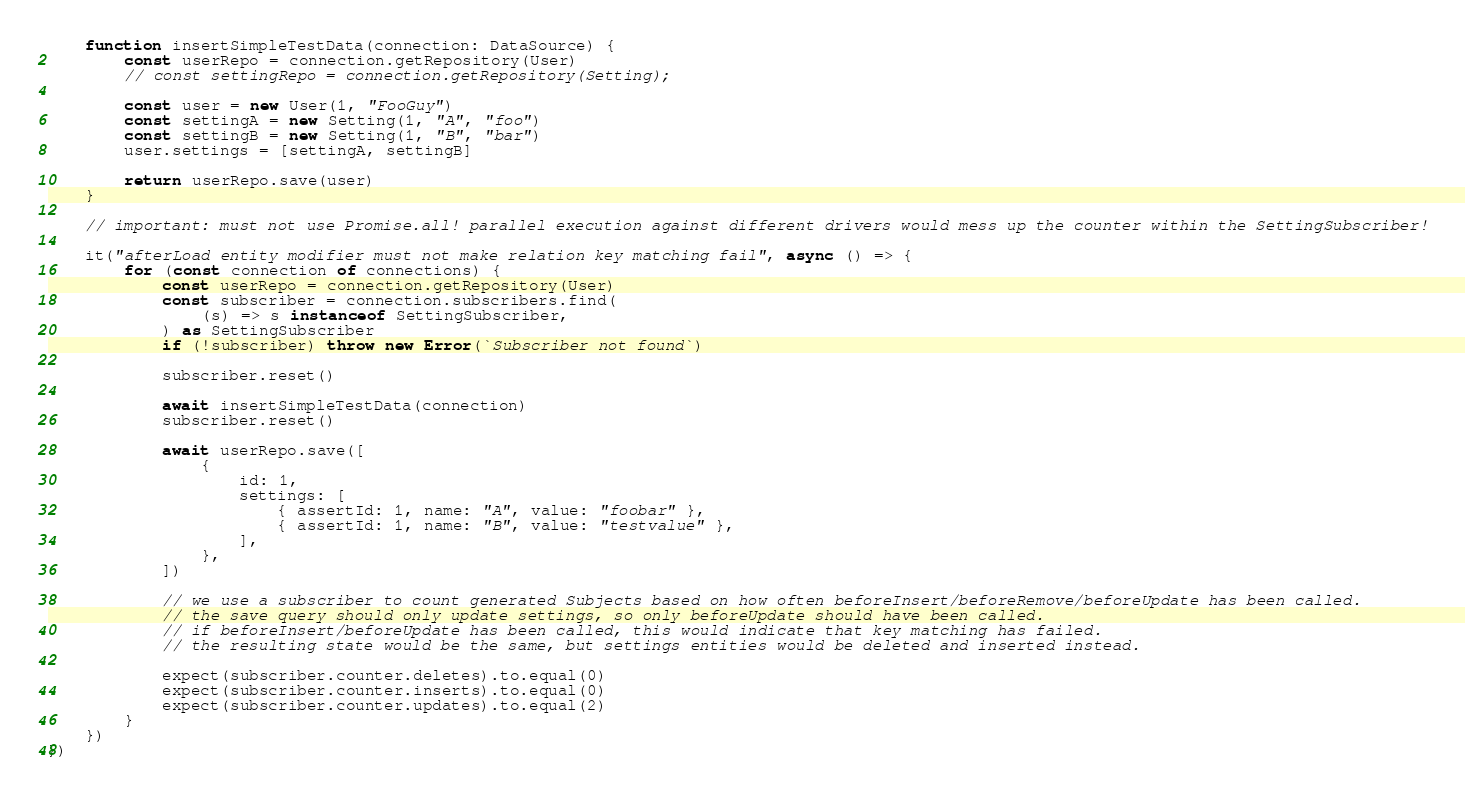Convert code to text. <code><loc_0><loc_0><loc_500><loc_500><_TypeScript_>    function insertSimpleTestData(connection: DataSource) {
        const userRepo = connection.getRepository(User)
        // const settingRepo = connection.getRepository(Setting);

        const user = new User(1, "FooGuy")
        const settingA = new Setting(1, "A", "foo")
        const settingB = new Setting(1, "B", "bar")
        user.settings = [settingA, settingB]

        return userRepo.save(user)
    }

    // important: must not use Promise.all! parallel execution against different drivers would mess up the counter within the SettingSubscriber!

    it("afterLoad entity modifier must not make relation key matching fail", async () => {
        for (const connection of connections) {
            const userRepo = connection.getRepository(User)
            const subscriber = connection.subscribers.find(
                (s) => s instanceof SettingSubscriber,
            ) as SettingSubscriber
            if (!subscriber) throw new Error(`Subscriber not found`)

            subscriber.reset()

            await insertSimpleTestData(connection)
            subscriber.reset()

            await userRepo.save([
                {
                    id: 1,
                    settings: [
                        { assertId: 1, name: "A", value: "foobar" },
                        { assertId: 1, name: "B", value: "testvalue" },
                    ],
                },
            ])

            // we use a subscriber to count generated Subjects based on how often beforeInsert/beforeRemove/beforeUpdate has been called.
            // the save query should only update settings, so only beforeUpdate should have been called.
            // if beforeInsert/beforeUpdate has been called, this would indicate that key matching has failed.
            // the resulting state would be the same, but settings entities would be deleted and inserted instead.

            expect(subscriber.counter.deletes).to.equal(0)
            expect(subscriber.counter.inserts).to.equal(0)
            expect(subscriber.counter.updates).to.equal(2)
        }
    })
})
</code> 